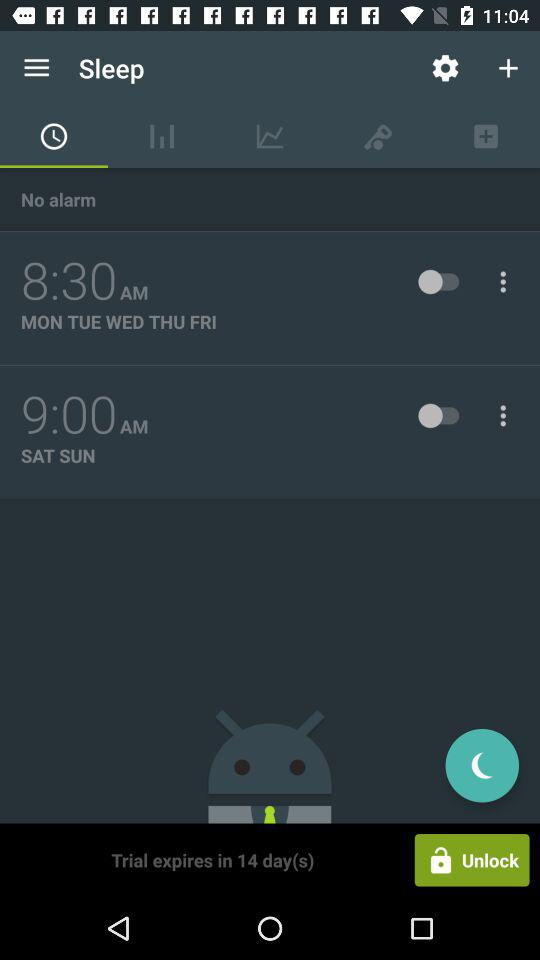What tab is selected? The selected tab is "Alarm". 